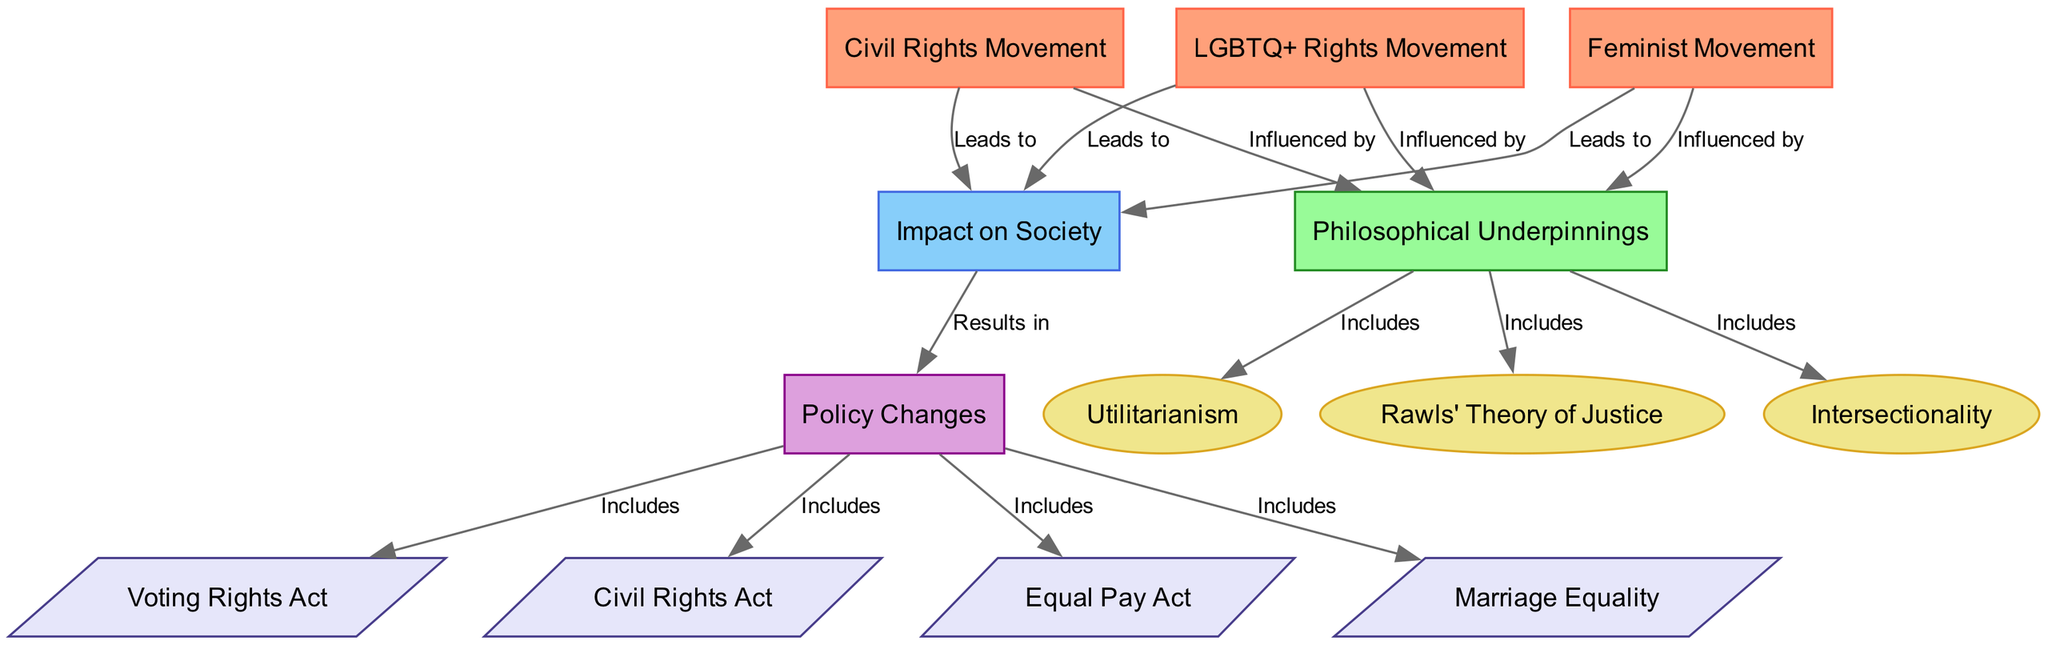What are the three main social justice movements illustrated in the diagram? The three main social justice movements shown are the Civil Rights Movement, Feminist Movement, and LGBTQ+ Rights Movement, which are represented as nodes in the diagram.
Answer: Civil Rights Movement, Feminist Movement, LGBTQ+ Rights Movement How many philosophical underpinnings are connected to the movements? The diagram shows three philosophical underpinnings connected to the social justice movements: Utilitarianism, Rawls' Theory of Justice, and Intersectionality, as indicated by the edges leading from the "Philosophical Underpinnings" node.
Answer: 3 Which social justice movement leads to policy changes? All three social justice movements (Civil Rights Movement, Feminist Movement, and LGBTQ+ Rights Movement) lead to the "Impact on Society" node, which in turn results in policy changes, as shown in the flow of the diagram.
Answer: Civil Rights Movement, Feminist Movement, LGBTQ+ Rights Movement What is the connection between Impact on Society and Policy Changes? The connection is indicated by an edge labeled "Results in," showing that "Impact on Society" directly leads to "Policy Changes." This suggests that societal impacts from the movements contribute to changes in policy.
Answer: Results in Which policy change is associated with the Civil Rights Act? The Civil Rights Act is connected to the "Policy Changes" node as one of its categories, indicated by the edge showing that it includes several specific policy changes stemming from "Policy Changes."
Answer: Civil Rights Act List one philosophical underpinning related to the Feminist Movement. The Feminist Movement is influenced by the "Philosophical Underpinnings" node, which includes Intersectionality. This connection indicates that Intersectionality is one of the philosophical frameworks underpinning the Feminist Movement according to the diagram.
Answer: Intersectionality How does the LGBTQ+ Rights Movement impact society according to the diagram? The LGBTQ+ Rights Movement influences the "Impact on Society" node within the diagram, suggesting that it leads to changes in societal attitudes or practices, which can also lead to further policy changes.
Answer: Leads to What type of relationships are present among the movements and philosophical underpinnings? The relationships include "Influenced by" for movements towards philosophical underpinnings and "Includes" for how philosophical ideas encompass concepts such as Utilitarianism or Intersectionality, highlighting a structured connection defined in the diagram.
Answer: Influenced by, Includes 